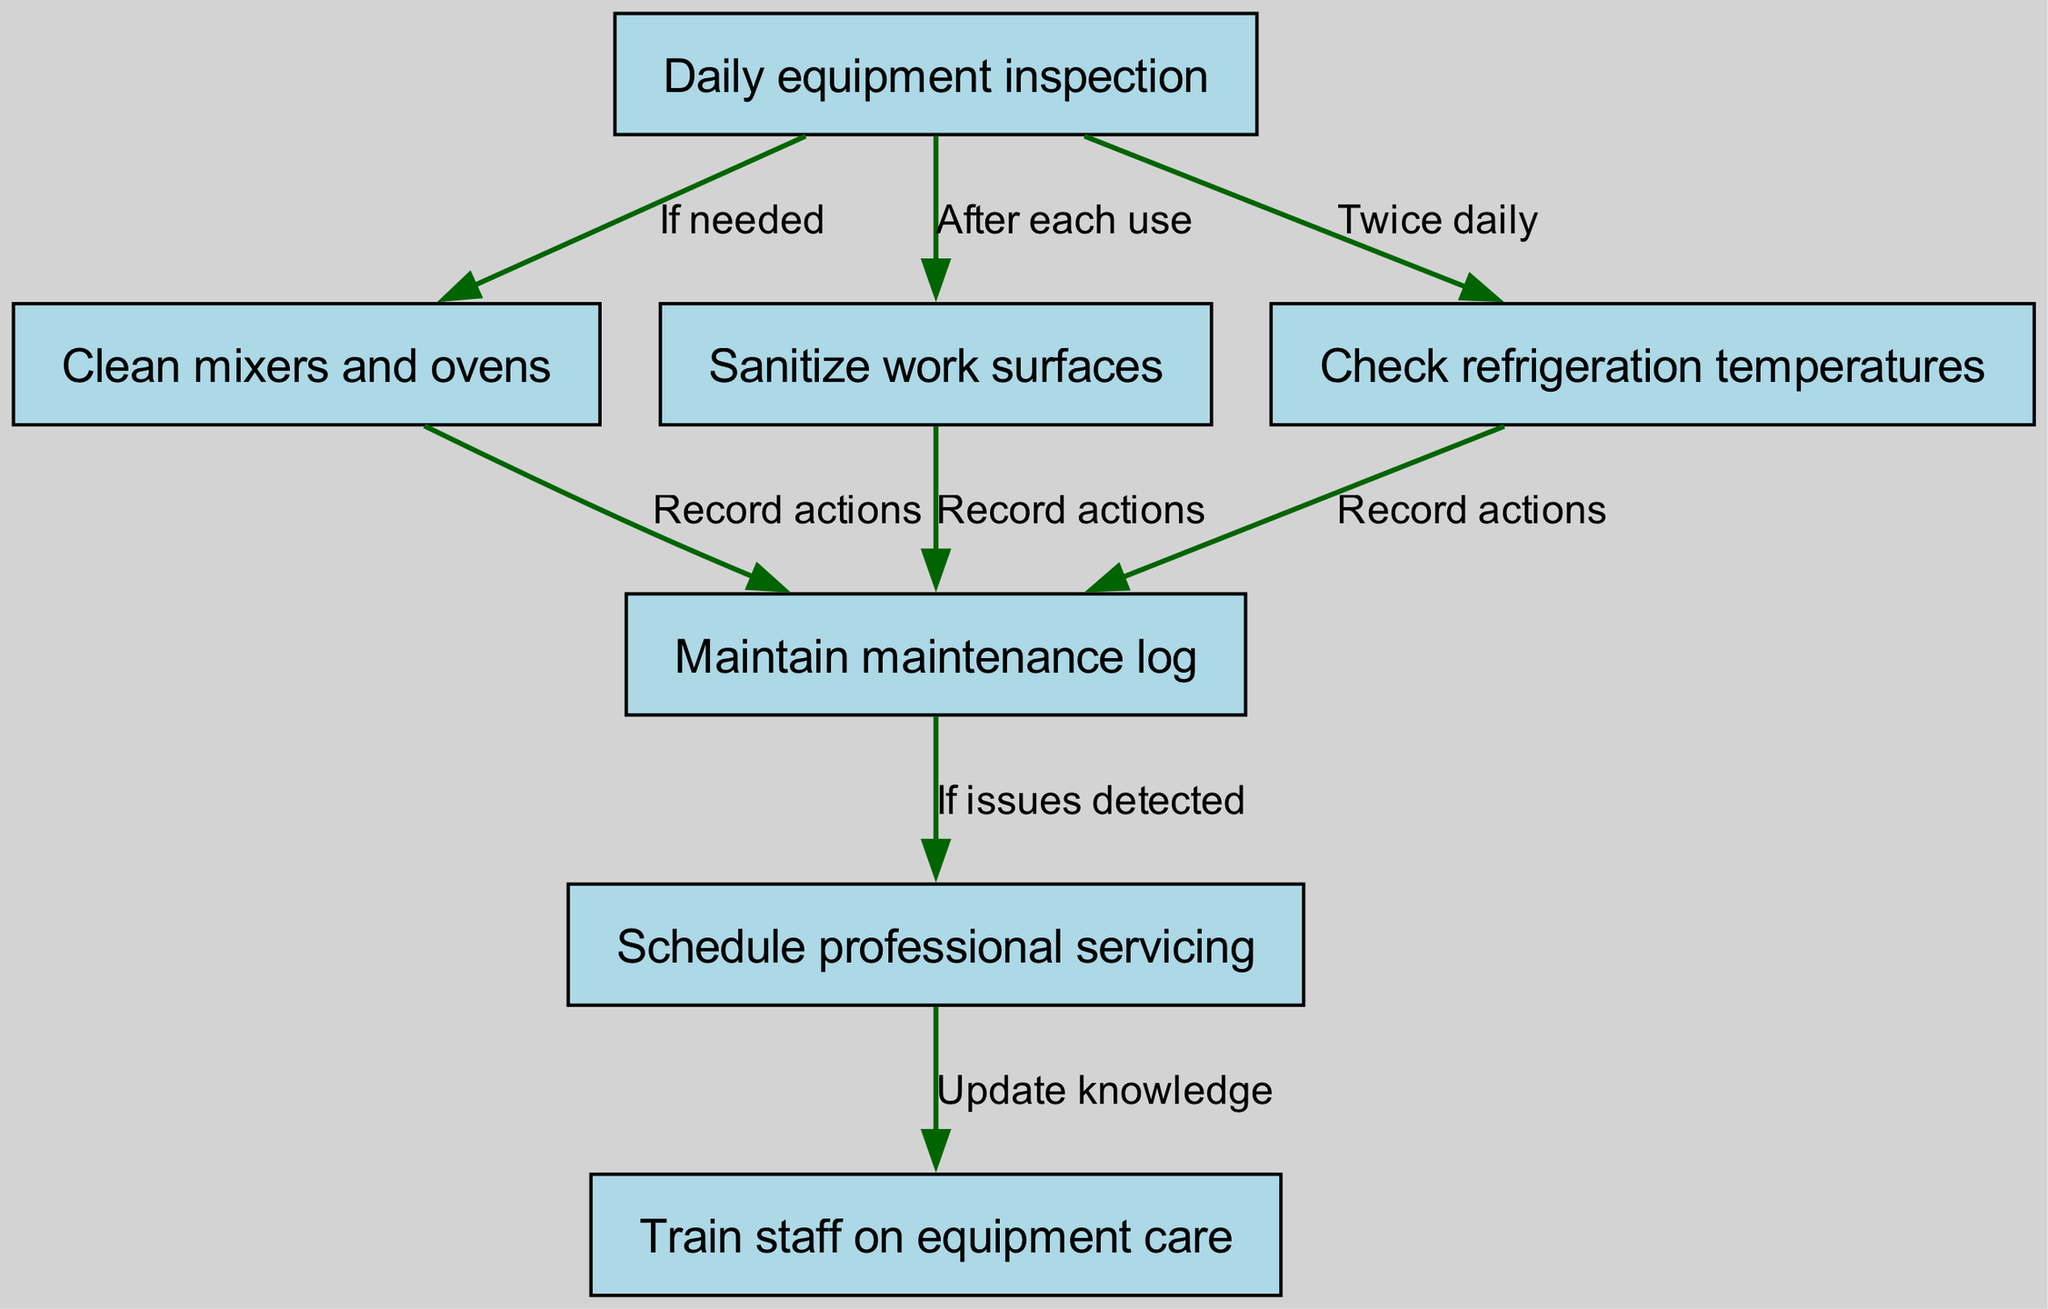What's the first node in the pathway? The first node in the diagram represents the initial action to be taken in the quality control process, which is "Daily equipment inspection".
Answer: Daily equipment inspection How many nodes are in the diagram? By counting the nodes listed in the data, there are a total of seven distinct steps or components in the pathway.
Answer: 7 What is the relationship between "Daily equipment inspection" and "Clean mixers and ovens"? The edge connecting these two nodes indicates that the action "Clean mixers and ovens" is contingent on the "Daily equipment inspection" node being completed and is labeled "If needed", implying it will be performed only if necessary after inspection.
Answer: If needed How often should refrigeration temperatures be checked? The labeled edge from "Daily equipment inspection" to "Check refrigeration temperatures" specifies it should occur "Twice daily", indicating the frequency of this task.
Answer: Twice daily What needs to happen if issues are detected during the maintenance log review? The edge connecting "Maintain maintenance log" and "Schedule professional servicing" indicates that if issues are detected in the log, the next step is to "Schedule professional servicing".
Answer: Schedule professional servicing What process follows from "Sanitize work surfaces"? The edge from "Sanitize work surfaces" to "Maintain maintenance log" indicates that after sanitizing, actions taken (sanitization) should be recorded in the maintenance log.
Answer: Record actions Which node involves training the staff? The last step in the diagram hears "Train staff on equipment care" which is connected to the "Schedule professional servicing", indicating that updating staff knowledge comes after professional servicing.
Answer: Train staff on equipment care What is the output if refrigeration temperatures are too high? If the temperatures checked at "Check refrigeration temperatures" are high, one would likely note these in the "Maintain maintenance log" and possibly proceed to "Schedule professional servicing" based on the relationship outlined in the edges of the diagram.
Answer: Schedule professional servicing 